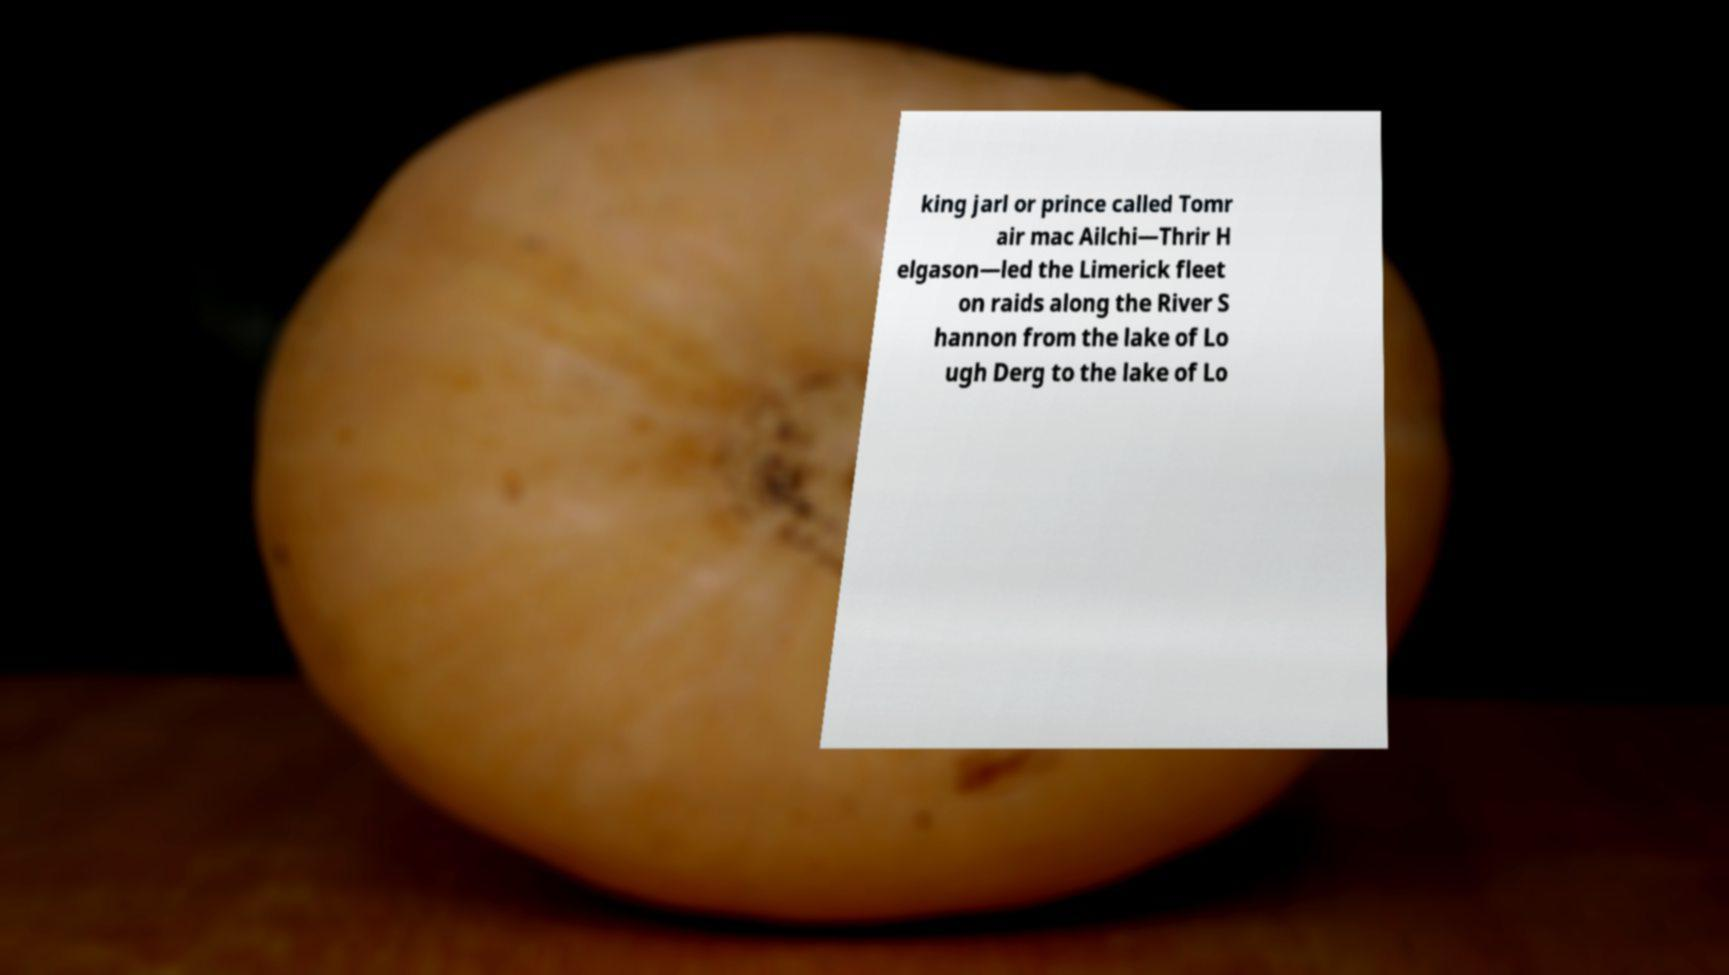For documentation purposes, I need the text within this image transcribed. Could you provide that? king jarl or prince called Tomr air mac Ailchi—Thrir H elgason—led the Limerick fleet on raids along the River S hannon from the lake of Lo ugh Derg to the lake of Lo 